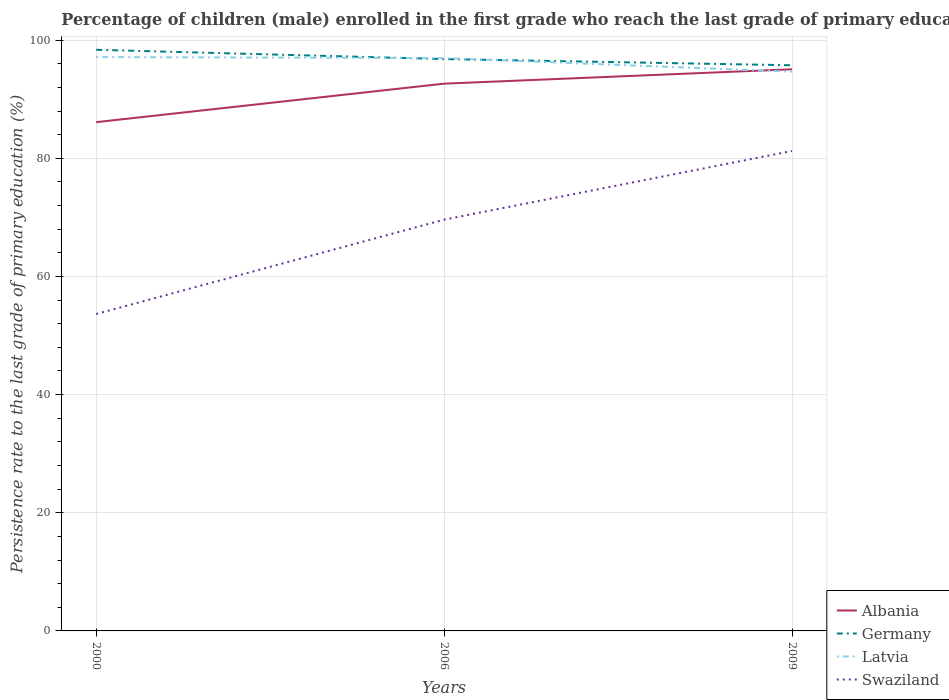How many different coloured lines are there?
Give a very brief answer. 4. Is the number of lines equal to the number of legend labels?
Make the answer very short. Yes. Across all years, what is the maximum persistence rate of children in Latvia?
Keep it short and to the point. 94.66. What is the total persistence rate of children in Germany in the graph?
Offer a terse response. 1.57. What is the difference between the highest and the second highest persistence rate of children in Latvia?
Your answer should be compact. 2.48. What is the difference between the highest and the lowest persistence rate of children in Swaziland?
Ensure brevity in your answer.  2. Is the persistence rate of children in Albania strictly greater than the persistence rate of children in Germany over the years?
Your answer should be compact. Yes. How many years are there in the graph?
Give a very brief answer. 3. What is the difference between two consecutive major ticks on the Y-axis?
Offer a terse response. 20. Does the graph contain grids?
Provide a short and direct response. Yes. Where does the legend appear in the graph?
Your answer should be very brief. Bottom right. How are the legend labels stacked?
Keep it short and to the point. Vertical. What is the title of the graph?
Offer a very short reply. Percentage of children (male) enrolled in the first grade who reach the last grade of primary education. Does "Middle income" appear as one of the legend labels in the graph?
Provide a succinct answer. No. What is the label or title of the X-axis?
Your response must be concise. Years. What is the label or title of the Y-axis?
Your answer should be very brief. Persistence rate to the last grade of primary education (%). What is the Persistence rate to the last grade of primary education (%) in Albania in 2000?
Your answer should be compact. 86.11. What is the Persistence rate to the last grade of primary education (%) of Germany in 2000?
Your response must be concise. 98.36. What is the Persistence rate to the last grade of primary education (%) of Latvia in 2000?
Provide a short and direct response. 97.13. What is the Persistence rate to the last grade of primary education (%) of Swaziland in 2000?
Your answer should be compact. 53.64. What is the Persistence rate to the last grade of primary education (%) of Albania in 2006?
Keep it short and to the point. 92.63. What is the Persistence rate to the last grade of primary education (%) in Germany in 2006?
Your answer should be compact. 96.79. What is the Persistence rate to the last grade of primary education (%) of Latvia in 2006?
Make the answer very short. 96.96. What is the Persistence rate to the last grade of primary education (%) in Swaziland in 2006?
Offer a terse response. 69.61. What is the Persistence rate to the last grade of primary education (%) in Albania in 2009?
Give a very brief answer. 95.07. What is the Persistence rate to the last grade of primary education (%) of Germany in 2009?
Make the answer very short. 95.74. What is the Persistence rate to the last grade of primary education (%) of Latvia in 2009?
Offer a terse response. 94.66. What is the Persistence rate to the last grade of primary education (%) in Swaziland in 2009?
Ensure brevity in your answer.  81.24. Across all years, what is the maximum Persistence rate to the last grade of primary education (%) in Albania?
Your answer should be compact. 95.07. Across all years, what is the maximum Persistence rate to the last grade of primary education (%) in Germany?
Your answer should be very brief. 98.36. Across all years, what is the maximum Persistence rate to the last grade of primary education (%) in Latvia?
Make the answer very short. 97.13. Across all years, what is the maximum Persistence rate to the last grade of primary education (%) in Swaziland?
Offer a very short reply. 81.24. Across all years, what is the minimum Persistence rate to the last grade of primary education (%) of Albania?
Keep it short and to the point. 86.11. Across all years, what is the minimum Persistence rate to the last grade of primary education (%) in Germany?
Provide a succinct answer. 95.74. Across all years, what is the minimum Persistence rate to the last grade of primary education (%) in Latvia?
Ensure brevity in your answer.  94.66. Across all years, what is the minimum Persistence rate to the last grade of primary education (%) of Swaziland?
Provide a succinct answer. 53.64. What is the total Persistence rate to the last grade of primary education (%) in Albania in the graph?
Ensure brevity in your answer.  273.81. What is the total Persistence rate to the last grade of primary education (%) of Germany in the graph?
Provide a succinct answer. 290.9. What is the total Persistence rate to the last grade of primary education (%) in Latvia in the graph?
Provide a short and direct response. 288.75. What is the total Persistence rate to the last grade of primary education (%) of Swaziland in the graph?
Keep it short and to the point. 204.49. What is the difference between the Persistence rate to the last grade of primary education (%) in Albania in 2000 and that in 2006?
Offer a very short reply. -6.52. What is the difference between the Persistence rate to the last grade of primary education (%) in Germany in 2000 and that in 2006?
Keep it short and to the point. 1.57. What is the difference between the Persistence rate to the last grade of primary education (%) of Latvia in 2000 and that in 2006?
Give a very brief answer. 0.17. What is the difference between the Persistence rate to the last grade of primary education (%) of Swaziland in 2000 and that in 2006?
Ensure brevity in your answer.  -15.97. What is the difference between the Persistence rate to the last grade of primary education (%) in Albania in 2000 and that in 2009?
Give a very brief answer. -8.95. What is the difference between the Persistence rate to the last grade of primary education (%) in Germany in 2000 and that in 2009?
Give a very brief answer. 2.62. What is the difference between the Persistence rate to the last grade of primary education (%) of Latvia in 2000 and that in 2009?
Offer a terse response. 2.48. What is the difference between the Persistence rate to the last grade of primary education (%) of Swaziland in 2000 and that in 2009?
Provide a succinct answer. -27.6. What is the difference between the Persistence rate to the last grade of primary education (%) of Albania in 2006 and that in 2009?
Give a very brief answer. -2.43. What is the difference between the Persistence rate to the last grade of primary education (%) of Germany in 2006 and that in 2009?
Offer a very short reply. 1.05. What is the difference between the Persistence rate to the last grade of primary education (%) of Latvia in 2006 and that in 2009?
Keep it short and to the point. 2.3. What is the difference between the Persistence rate to the last grade of primary education (%) of Swaziland in 2006 and that in 2009?
Offer a terse response. -11.63. What is the difference between the Persistence rate to the last grade of primary education (%) in Albania in 2000 and the Persistence rate to the last grade of primary education (%) in Germany in 2006?
Keep it short and to the point. -10.68. What is the difference between the Persistence rate to the last grade of primary education (%) of Albania in 2000 and the Persistence rate to the last grade of primary education (%) of Latvia in 2006?
Your response must be concise. -10.85. What is the difference between the Persistence rate to the last grade of primary education (%) in Albania in 2000 and the Persistence rate to the last grade of primary education (%) in Swaziland in 2006?
Your response must be concise. 16.5. What is the difference between the Persistence rate to the last grade of primary education (%) in Germany in 2000 and the Persistence rate to the last grade of primary education (%) in Latvia in 2006?
Your response must be concise. 1.4. What is the difference between the Persistence rate to the last grade of primary education (%) of Germany in 2000 and the Persistence rate to the last grade of primary education (%) of Swaziland in 2006?
Ensure brevity in your answer.  28.75. What is the difference between the Persistence rate to the last grade of primary education (%) of Latvia in 2000 and the Persistence rate to the last grade of primary education (%) of Swaziland in 2006?
Provide a short and direct response. 27.52. What is the difference between the Persistence rate to the last grade of primary education (%) in Albania in 2000 and the Persistence rate to the last grade of primary education (%) in Germany in 2009?
Provide a short and direct response. -9.63. What is the difference between the Persistence rate to the last grade of primary education (%) of Albania in 2000 and the Persistence rate to the last grade of primary education (%) of Latvia in 2009?
Provide a short and direct response. -8.54. What is the difference between the Persistence rate to the last grade of primary education (%) of Albania in 2000 and the Persistence rate to the last grade of primary education (%) of Swaziland in 2009?
Your answer should be compact. 4.88. What is the difference between the Persistence rate to the last grade of primary education (%) in Germany in 2000 and the Persistence rate to the last grade of primary education (%) in Latvia in 2009?
Provide a succinct answer. 3.71. What is the difference between the Persistence rate to the last grade of primary education (%) in Germany in 2000 and the Persistence rate to the last grade of primary education (%) in Swaziland in 2009?
Ensure brevity in your answer.  17.13. What is the difference between the Persistence rate to the last grade of primary education (%) of Latvia in 2000 and the Persistence rate to the last grade of primary education (%) of Swaziland in 2009?
Your answer should be compact. 15.89. What is the difference between the Persistence rate to the last grade of primary education (%) of Albania in 2006 and the Persistence rate to the last grade of primary education (%) of Germany in 2009?
Make the answer very short. -3.11. What is the difference between the Persistence rate to the last grade of primary education (%) in Albania in 2006 and the Persistence rate to the last grade of primary education (%) in Latvia in 2009?
Offer a very short reply. -2.03. What is the difference between the Persistence rate to the last grade of primary education (%) in Albania in 2006 and the Persistence rate to the last grade of primary education (%) in Swaziland in 2009?
Ensure brevity in your answer.  11.39. What is the difference between the Persistence rate to the last grade of primary education (%) of Germany in 2006 and the Persistence rate to the last grade of primary education (%) of Latvia in 2009?
Provide a succinct answer. 2.14. What is the difference between the Persistence rate to the last grade of primary education (%) in Germany in 2006 and the Persistence rate to the last grade of primary education (%) in Swaziland in 2009?
Your answer should be compact. 15.55. What is the difference between the Persistence rate to the last grade of primary education (%) in Latvia in 2006 and the Persistence rate to the last grade of primary education (%) in Swaziland in 2009?
Your answer should be very brief. 15.72. What is the average Persistence rate to the last grade of primary education (%) of Albania per year?
Give a very brief answer. 91.27. What is the average Persistence rate to the last grade of primary education (%) of Germany per year?
Your answer should be compact. 96.97. What is the average Persistence rate to the last grade of primary education (%) of Latvia per year?
Ensure brevity in your answer.  96.25. What is the average Persistence rate to the last grade of primary education (%) of Swaziland per year?
Your response must be concise. 68.16. In the year 2000, what is the difference between the Persistence rate to the last grade of primary education (%) in Albania and Persistence rate to the last grade of primary education (%) in Germany?
Your response must be concise. -12.25. In the year 2000, what is the difference between the Persistence rate to the last grade of primary education (%) in Albania and Persistence rate to the last grade of primary education (%) in Latvia?
Ensure brevity in your answer.  -11.02. In the year 2000, what is the difference between the Persistence rate to the last grade of primary education (%) of Albania and Persistence rate to the last grade of primary education (%) of Swaziland?
Offer a terse response. 32.47. In the year 2000, what is the difference between the Persistence rate to the last grade of primary education (%) in Germany and Persistence rate to the last grade of primary education (%) in Latvia?
Your answer should be very brief. 1.23. In the year 2000, what is the difference between the Persistence rate to the last grade of primary education (%) of Germany and Persistence rate to the last grade of primary education (%) of Swaziland?
Offer a very short reply. 44.72. In the year 2000, what is the difference between the Persistence rate to the last grade of primary education (%) of Latvia and Persistence rate to the last grade of primary education (%) of Swaziland?
Offer a very short reply. 43.49. In the year 2006, what is the difference between the Persistence rate to the last grade of primary education (%) in Albania and Persistence rate to the last grade of primary education (%) in Germany?
Your answer should be very brief. -4.16. In the year 2006, what is the difference between the Persistence rate to the last grade of primary education (%) of Albania and Persistence rate to the last grade of primary education (%) of Latvia?
Provide a succinct answer. -4.33. In the year 2006, what is the difference between the Persistence rate to the last grade of primary education (%) in Albania and Persistence rate to the last grade of primary education (%) in Swaziland?
Provide a short and direct response. 23.02. In the year 2006, what is the difference between the Persistence rate to the last grade of primary education (%) of Germany and Persistence rate to the last grade of primary education (%) of Latvia?
Ensure brevity in your answer.  -0.17. In the year 2006, what is the difference between the Persistence rate to the last grade of primary education (%) of Germany and Persistence rate to the last grade of primary education (%) of Swaziland?
Offer a terse response. 27.18. In the year 2006, what is the difference between the Persistence rate to the last grade of primary education (%) in Latvia and Persistence rate to the last grade of primary education (%) in Swaziland?
Provide a succinct answer. 27.35. In the year 2009, what is the difference between the Persistence rate to the last grade of primary education (%) of Albania and Persistence rate to the last grade of primary education (%) of Germany?
Make the answer very short. -0.68. In the year 2009, what is the difference between the Persistence rate to the last grade of primary education (%) of Albania and Persistence rate to the last grade of primary education (%) of Latvia?
Offer a very short reply. 0.41. In the year 2009, what is the difference between the Persistence rate to the last grade of primary education (%) in Albania and Persistence rate to the last grade of primary education (%) in Swaziland?
Your response must be concise. 13.83. In the year 2009, what is the difference between the Persistence rate to the last grade of primary education (%) of Germany and Persistence rate to the last grade of primary education (%) of Latvia?
Offer a very short reply. 1.09. In the year 2009, what is the difference between the Persistence rate to the last grade of primary education (%) of Germany and Persistence rate to the last grade of primary education (%) of Swaziland?
Your response must be concise. 14.5. In the year 2009, what is the difference between the Persistence rate to the last grade of primary education (%) in Latvia and Persistence rate to the last grade of primary education (%) in Swaziland?
Ensure brevity in your answer.  13.42. What is the ratio of the Persistence rate to the last grade of primary education (%) of Albania in 2000 to that in 2006?
Give a very brief answer. 0.93. What is the ratio of the Persistence rate to the last grade of primary education (%) in Germany in 2000 to that in 2006?
Provide a short and direct response. 1.02. What is the ratio of the Persistence rate to the last grade of primary education (%) in Latvia in 2000 to that in 2006?
Your answer should be compact. 1. What is the ratio of the Persistence rate to the last grade of primary education (%) in Swaziland in 2000 to that in 2006?
Offer a very short reply. 0.77. What is the ratio of the Persistence rate to the last grade of primary education (%) in Albania in 2000 to that in 2009?
Keep it short and to the point. 0.91. What is the ratio of the Persistence rate to the last grade of primary education (%) in Germany in 2000 to that in 2009?
Your answer should be very brief. 1.03. What is the ratio of the Persistence rate to the last grade of primary education (%) of Latvia in 2000 to that in 2009?
Make the answer very short. 1.03. What is the ratio of the Persistence rate to the last grade of primary education (%) in Swaziland in 2000 to that in 2009?
Make the answer very short. 0.66. What is the ratio of the Persistence rate to the last grade of primary education (%) in Albania in 2006 to that in 2009?
Ensure brevity in your answer.  0.97. What is the ratio of the Persistence rate to the last grade of primary education (%) in Latvia in 2006 to that in 2009?
Your answer should be very brief. 1.02. What is the ratio of the Persistence rate to the last grade of primary education (%) of Swaziland in 2006 to that in 2009?
Your answer should be compact. 0.86. What is the difference between the highest and the second highest Persistence rate to the last grade of primary education (%) in Albania?
Keep it short and to the point. 2.43. What is the difference between the highest and the second highest Persistence rate to the last grade of primary education (%) in Germany?
Keep it short and to the point. 1.57. What is the difference between the highest and the second highest Persistence rate to the last grade of primary education (%) of Latvia?
Offer a very short reply. 0.17. What is the difference between the highest and the second highest Persistence rate to the last grade of primary education (%) in Swaziland?
Your answer should be compact. 11.63. What is the difference between the highest and the lowest Persistence rate to the last grade of primary education (%) in Albania?
Provide a short and direct response. 8.95. What is the difference between the highest and the lowest Persistence rate to the last grade of primary education (%) of Germany?
Offer a terse response. 2.62. What is the difference between the highest and the lowest Persistence rate to the last grade of primary education (%) in Latvia?
Make the answer very short. 2.48. What is the difference between the highest and the lowest Persistence rate to the last grade of primary education (%) in Swaziland?
Your answer should be very brief. 27.6. 